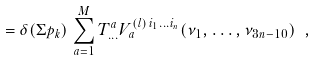Convert formula to latex. <formula><loc_0><loc_0><loc_500><loc_500>= \delta ( \Sigma p _ { k } ) \, \sum _ { a = 1 } ^ { M } T _ { \dots } ^ { a } V _ { a } ^ { ( l ) \, i _ { 1 } \dots i _ { n } } ( \nu _ { 1 } , \dots , \nu _ { 3 n - 1 0 } ) \ ,</formula> 